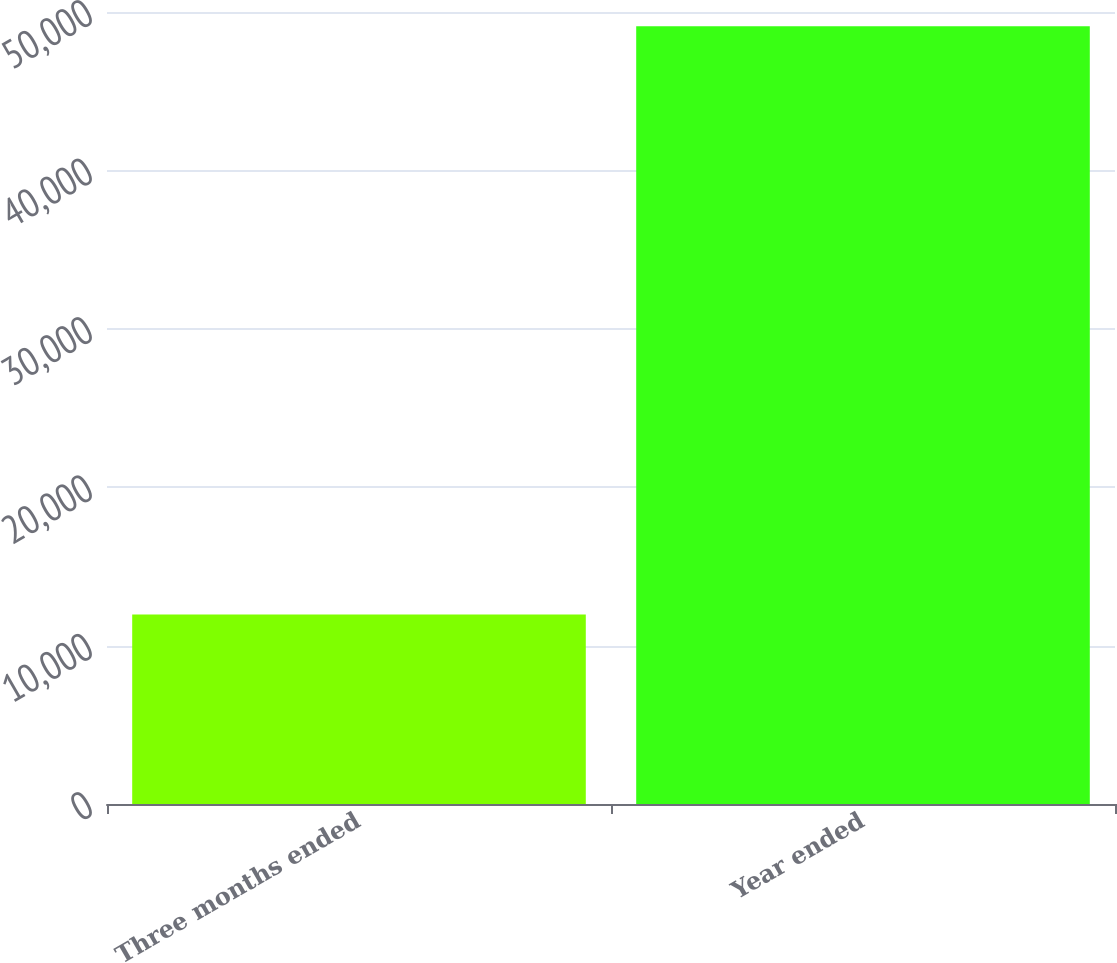Convert chart to OTSL. <chart><loc_0><loc_0><loc_500><loc_500><bar_chart><fcel>Three months ended<fcel>Year ended<nl><fcel>11959<fcel>49097<nl></chart> 